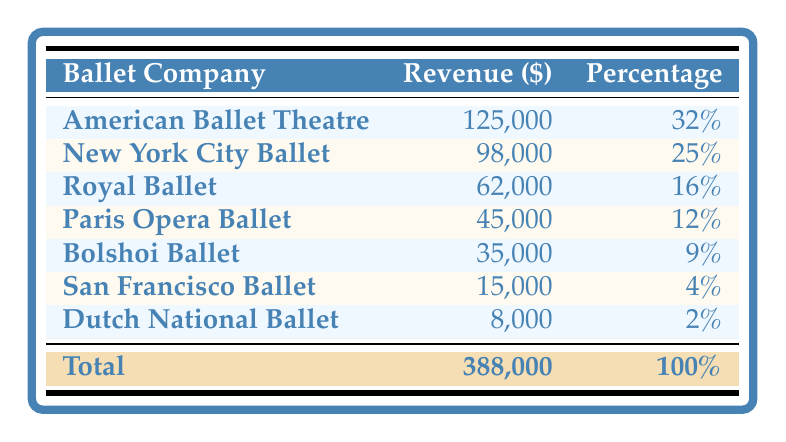What is the revenue generated by the American Ballet Theatre? According to the table, the revenue for the American Ballet Theatre is listed directly as $125,000.
Answer: $125,000 Which ballet company has the highest revenue? The American Ballet Theatre has the highest revenue listed in the table, with a total of $125,000.
Answer: American Ballet Theatre What percentage of the total revenue comes from the New York City Ballet? The New York City Ballet contributes 25% to the total revenue as stated in the percentage column.
Answer: 25% Is the revenue from the Bolshoi Ballet greater than the revenue from the San Francisco Ballet? The revenue from the Bolshoi Ballet is $35,000 and the San Francisco Ballet is $15,000, so $35,000 is indeed greater than $15,000.
Answer: Yes What is the combined revenue of the Royal Ballet and Paris Opera Ballet? Adding the revenue from the Royal Ballet ($62,000) and the Paris Opera Ballet ($45,000) gives a total of $107,000 ($62,000 + $45,000 = $107,000).
Answer: $107,000 Which ballet company contributes the least to the total revenue? The Dutch National Ballet contributes the least with a revenue of $8,000, as shown in the table.
Answer: Dutch National Ballet What is the total revenue of all the ballet companies listed? The total revenue is explicitly stated in the table as $388,000, which is the sum of the individual revenues of all the ballet companies.
Answer: $388,000 What is the average revenue from the ballet companies featured? The average revenue is calculated by dividing the total revenue of $388,000 by the number of companies listed, which is 7. So, $388,000/7 gives approximately $55,429.
Answer: $55,429 Does the revenue from the Paris Opera Ballet exceed that of the Dutch National Ballet? The Paris Opera Ballet revenue is $45,000 while Dutch National Ballet revenue is $8,000, thus $45,000 is greater than $8,000.
Answer: Yes 